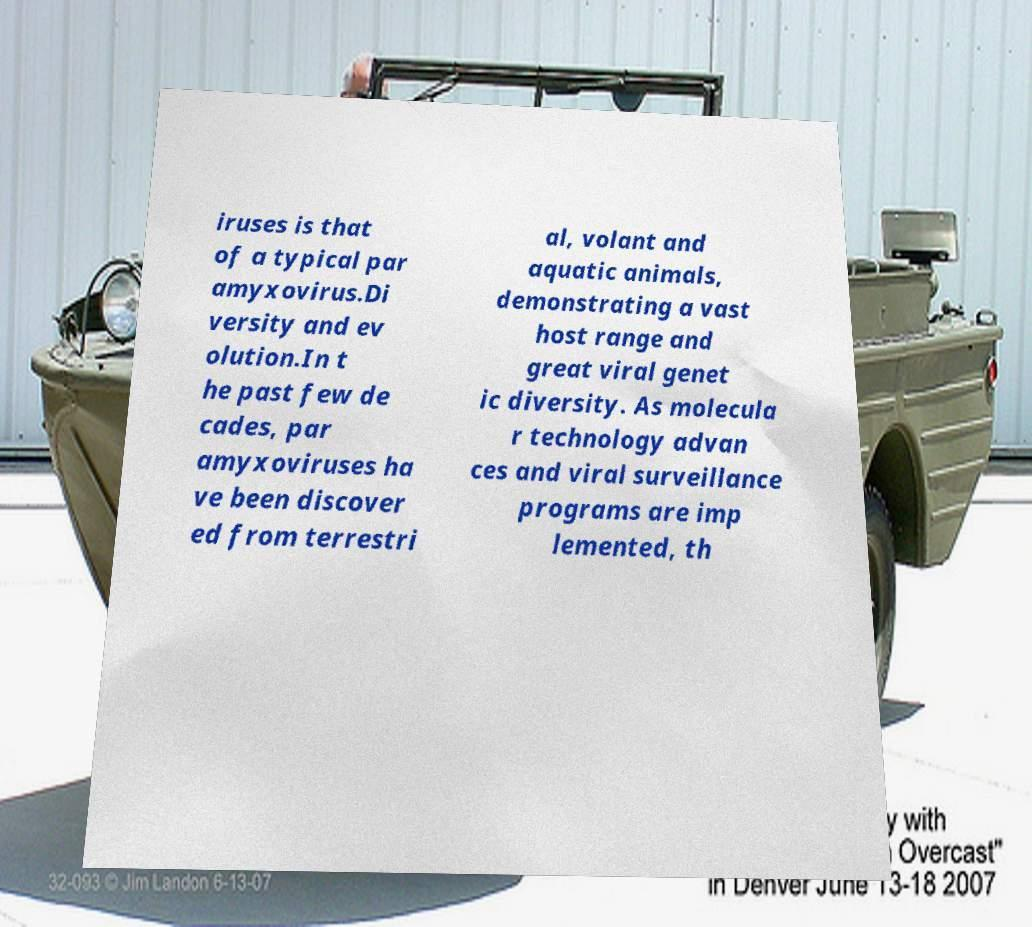Could you assist in decoding the text presented in this image and type it out clearly? iruses is that of a typical par amyxovirus.Di versity and ev olution.In t he past few de cades, par amyxoviruses ha ve been discover ed from terrestri al, volant and aquatic animals, demonstrating a vast host range and great viral genet ic diversity. As molecula r technology advan ces and viral surveillance programs are imp lemented, th 